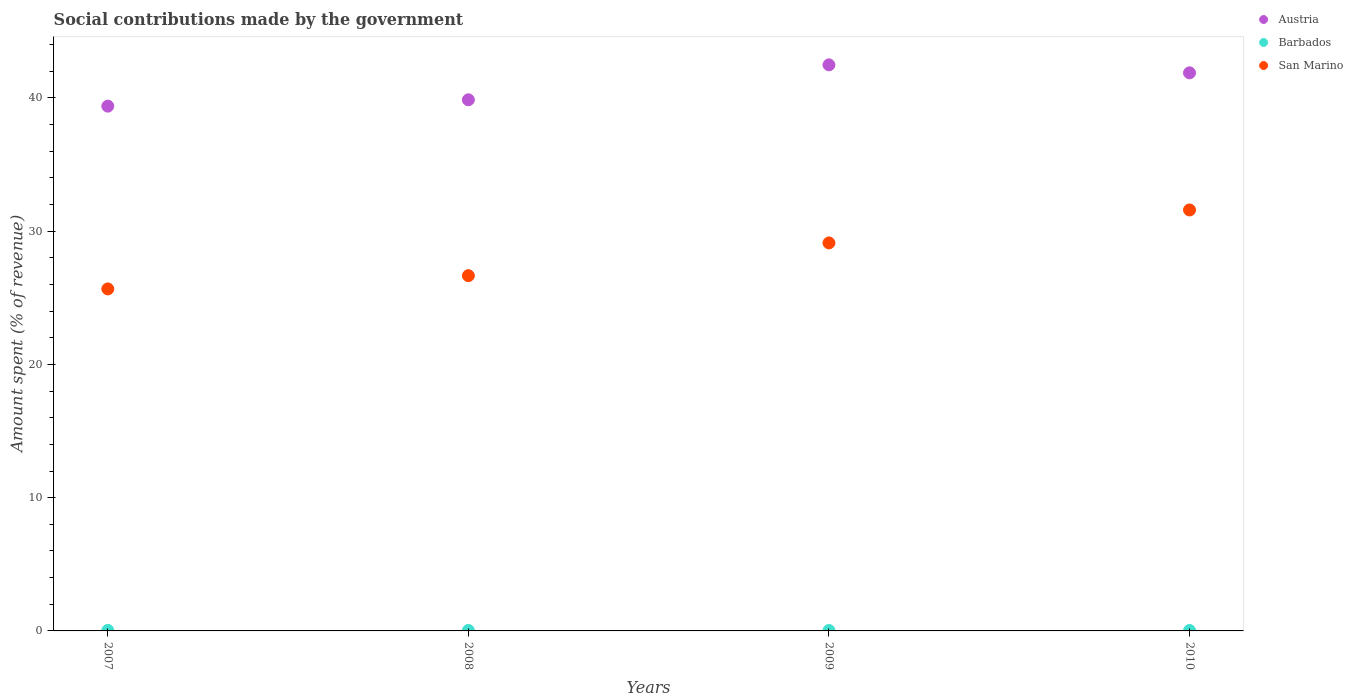How many different coloured dotlines are there?
Offer a very short reply. 3. Is the number of dotlines equal to the number of legend labels?
Offer a very short reply. Yes. What is the amount spent (in %) on social contributions in San Marino in 2010?
Provide a short and direct response. 31.59. Across all years, what is the maximum amount spent (in %) on social contributions in San Marino?
Ensure brevity in your answer.  31.59. Across all years, what is the minimum amount spent (in %) on social contributions in San Marino?
Your answer should be compact. 25.67. In which year was the amount spent (in %) on social contributions in Austria minimum?
Give a very brief answer. 2007. What is the total amount spent (in %) on social contributions in Austria in the graph?
Offer a very short reply. 163.62. What is the difference between the amount spent (in %) on social contributions in San Marino in 2009 and that in 2010?
Offer a terse response. -2.47. What is the difference between the amount spent (in %) on social contributions in Austria in 2008 and the amount spent (in %) on social contributions in Barbados in 2007?
Provide a succinct answer. 39.82. What is the average amount spent (in %) on social contributions in Barbados per year?
Provide a short and direct response. 0.03. In the year 2008, what is the difference between the amount spent (in %) on social contributions in Austria and amount spent (in %) on social contributions in Barbados?
Offer a terse response. 39.83. What is the ratio of the amount spent (in %) on social contributions in Austria in 2009 to that in 2010?
Provide a short and direct response. 1.01. Is the amount spent (in %) on social contributions in Austria in 2008 less than that in 2010?
Keep it short and to the point. Yes. Is the difference between the amount spent (in %) on social contributions in Austria in 2008 and 2009 greater than the difference between the amount spent (in %) on social contributions in Barbados in 2008 and 2009?
Keep it short and to the point. No. What is the difference between the highest and the second highest amount spent (in %) on social contributions in San Marino?
Your answer should be compact. 2.47. What is the difference between the highest and the lowest amount spent (in %) on social contributions in Austria?
Your answer should be very brief. 3.1. In how many years, is the amount spent (in %) on social contributions in San Marino greater than the average amount spent (in %) on social contributions in San Marino taken over all years?
Give a very brief answer. 2. Is the sum of the amount spent (in %) on social contributions in San Marino in 2008 and 2009 greater than the maximum amount spent (in %) on social contributions in Barbados across all years?
Your answer should be compact. Yes. Is it the case that in every year, the sum of the amount spent (in %) on social contributions in San Marino and amount spent (in %) on social contributions in Austria  is greater than the amount spent (in %) on social contributions in Barbados?
Offer a terse response. Yes. Does the amount spent (in %) on social contributions in Austria monotonically increase over the years?
Your answer should be very brief. No. Is the amount spent (in %) on social contributions in Barbados strictly greater than the amount spent (in %) on social contributions in Austria over the years?
Provide a succinct answer. No. How many dotlines are there?
Offer a terse response. 3. Are the values on the major ticks of Y-axis written in scientific E-notation?
Give a very brief answer. No. Does the graph contain grids?
Your response must be concise. No. Where does the legend appear in the graph?
Provide a short and direct response. Top right. How many legend labels are there?
Offer a terse response. 3. How are the legend labels stacked?
Make the answer very short. Vertical. What is the title of the graph?
Your answer should be very brief. Social contributions made by the government. Does "Jordan" appear as one of the legend labels in the graph?
Your answer should be compact. No. What is the label or title of the Y-axis?
Make the answer very short. Amount spent (% of revenue). What is the Amount spent (% of revenue) in Austria in 2007?
Your response must be concise. 39.39. What is the Amount spent (% of revenue) of Barbados in 2007?
Your answer should be very brief. 0.04. What is the Amount spent (% of revenue) in San Marino in 2007?
Ensure brevity in your answer.  25.67. What is the Amount spent (% of revenue) in Austria in 2008?
Provide a succinct answer. 39.86. What is the Amount spent (% of revenue) of Barbados in 2008?
Offer a very short reply. 0.04. What is the Amount spent (% of revenue) in San Marino in 2008?
Provide a succinct answer. 26.66. What is the Amount spent (% of revenue) in Austria in 2009?
Your response must be concise. 42.48. What is the Amount spent (% of revenue) in Barbados in 2009?
Offer a terse response. 0.03. What is the Amount spent (% of revenue) in San Marino in 2009?
Your response must be concise. 29.12. What is the Amount spent (% of revenue) of Austria in 2010?
Your answer should be very brief. 41.89. What is the Amount spent (% of revenue) in Barbados in 2010?
Make the answer very short. 0.03. What is the Amount spent (% of revenue) in San Marino in 2010?
Make the answer very short. 31.59. Across all years, what is the maximum Amount spent (% of revenue) of Austria?
Ensure brevity in your answer.  42.48. Across all years, what is the maximum Amount spent (% of revenue) in Barbados?
Offer a very short reply. 0.04. Across all years, what is the maximum Amount spent (% of revenue) of San Marino?
Ensure brevity in your answer.  31.59. Across all years, what is the minimum Amount spent (% of revenue) in Austria?
Offer a terse response. 39.39. Across all years, what is the minimum Amount spent (% of revenue) in Barbados?
Offer a terse response. 0.03. Across all years, what is the minimum Amount spent (% of revenue) in San Marino?
Your answer should be compact. 25.67. What is the total Amount spent (% of revenue) of Austria in the graph?
Your answer should be compact. 163.62. What is the total Amount spent (% of revenue) of Barbados in the graph?
Your response must be concise. 0.14. What is the total Amount spent (% of revenue) in San Marino in the graph?
Provide a succinct answer. 113.05. What is the difference between the Amount spent (% of revenue) of Austria in 2007 and that in 2008?
Keep it short and to the point. -0.48. What is the difference between the Amount spent (% of revenue) of Barbados in 2007 and that in 2008?
Ensure brevity in your answer.  0. What is the difference between the Amount spent (% of revenue) in San Marino in 2007 and that in 2008?
Offer a very short reply. -0.99. What is the difference between the Amount spent (% of revenue) in Austria in 2007 and that in 2009?
Make the answer very short. -3.1. What is the difference between the Amount spent (% of revenue) of Barbados in 2007 and that in 2009?
Your answer should be compact. 0.01. What is the difference between the Amount spent (% of revenue) in San Marino in 2007 and that in 2009?
Provide a succinct answer. -3.45. What is the difference between the Amount spent (% of revenue) in Austria in 2007 and that in 2010?
Offer a very short reply. -2.5. What is the difference between the Amount spent (% of revenue) of Barbados in 2007 and that in 2010?
Your answer should be very brief. 0.01. What is the difference between the Amount spent (% of revenue) in San Marino in 2007 and that in 2010?
Provide a succinct answer. -5.93. What is the difference between the Amount spent (% of revenue) of Austria in 2008 and that in 2009?
Ensure brevity in your answer.  -2.62. What is the difference between the Amount spent (% of revenue) of Barbados in 2008 and that in 2009?
Make the answer very short. 0.01. What is the difference between the Amount spent (% of revenue) in San Marino in 2008 and that in 2009?
Your answer should be very brief. -2.46. What is the difference between the Amount spent (% of revenue) in Austria in 2008 and that in 2010?
Ensure brevity in your answer.  -2.02. What is the difference between the Amount spent (% of revenue) of Barbados in 2008 and that in 2010?
Ensure brevity in your answer.  0. What is the difference between the Amount spent (% of revenue) of San Marino in 2008 and that in 2010?
Your response must be concise. -4.93. What is the difference between the Amount spent (% of revenue) in Austria in 2009 and that in 2010?
Keep it short and to the point. 0.6. What is the difference between the Amount spent (% of revenue) in Barbados in 2009 and that in 2010?
Your answer should be very brief. -0. What is the difference between the Amount spent (% of revenue) in San Marino in 2009 and that in 2010?
Your answer should be compact. -2.47. What is the difference between the Amount spent (% of revenue) in Austria in 2007 and the Amount spent (% of revenue) in Barbados in 2008?
Ensure brevity in your answer.  39.35. What is the difference between the Amount spent (% of revenue) of Austria in 2007 and the Amount spent (% of revenue) of San Marino in 2008?
Provide a succinct answer. 12.72. What is the difference between the Amount spent (% of revenue) in Barbados in 2007 and the Amount spent (% of revenue) in San Marino in 2008?
Ensure brevity in your answer.  -26.62. What is the difference between the Amount spent (% of revenue) in Austria in 2007 and the Amount spent (% of revenue) in Barbados in 2009?
Offer a very short reply. 39.36. What is the difference between the Amount spent (% of revenue) of Austria in 2007 and the Amount spent (% of revenue) of San Marino in 2009?
Provide a succinct answer. 10.27. What is the difference between the Amount spent (% of revenue) in Barbados in 2007 and the Amount spent (% of revenue) in San Marino in 2009?
Your answer should be compact. -29.08. What is the difference between the Amount spent (% of revenue) of Austria in 2007 and the Amount spent (% of revenue) of Barbados in 2010?
Give a very brief answer. 39.35. What is the difference between the Amount spent (% of revenue) of Austria in 2007 and the Amount spent (% of revenue) of San Marino in 2010?
Keep it short and to the point. 7.79. What is the difference between the Amount spent (% of revenue) of Barbados in 2007 and the Amount spent (% of revenue) of San Marino in 2010?
Your answer should be compact. -31.55. What is the difference between the Amount spent (% of revenue) in Austria in 2008 and the Amount spent (% of revenue) in Barbados in 2009?
Give a very brief answer. 39.83. What is the difference between the Amount spent (% of revenue) of Austria in 2008 and the Amount spent (% of revenue) of San Marino in 2009?
Ensure brevity in your answer.  10.74. What is the difference between the Amount spent (% of revenue) of Barbados in 2008 and the Amount spent (% of revenue) of San Marino in 2009?
Your answer should be compact. -29.08. What is the difference between the Amount spent (% of revenue) of Austria in 2008 and the Amount spent (% of revenue) of Barbados in 2010?
Provide a short and direct response. 39.83. What is the difference between the Amount spent (% of revenue) of Austria in 2008 and the Amount spent (% of revenue) of San Marino in 2010?
Provide a succinct answer. 8.27. What is the difference between the Amount spent (% of revenue) of Barbados in 2008 and the Amount spent (% of revenue) of San Marino in 2010?
Ensure brevity in your answer.  -31.56. What is the difference between the Amount spent (% of revenue) in Austria in 2009 and the Amount spent (% of revenue) in Barbados in 2010?
Ensure brevity in your answer.  42.45. What is the difference between the Amount spent (% of revenue) of Austria in 2009 and the Amount spent (% of revenue) of San Marino in 2010?
Give a very brief answer. 10.89. What is the difference between the Amount spent (% of revenue) in Barbados in 2009 and the Amount spent (% of revenue) in San Marino in 2010?
Give a very brief answer. -31.56. What is the average Amount spent (% of revenue) of Austria per year?
Provide a short and direct response. 40.9. What is the average Amount spent (% of revenue) of Barbados per year?
Make the answer very short. 0.03. What is the average Amount spent (% of revenue) in San Marino per year?
Offer a terse response. 28.26. In the year 2007, what is the difference between the Amount spent (% of revenue) in Austria and Amount spent (% of revenue) in Barbados?
Your response must be concise. 39.35. In the year 2007, what is the difference between the Amount spent (% of revenue) of Austria and Amount spent (% of revenue) of San Marino?
Your answer should be compact. 13.72. In the year 2007, what is the difference between the Amount spent (% of revenue) of Barbados and Amount spent (% of revenue) of San Marino?
Provide a short and direct response. -25.63. In the year 2008, what is the difference between the Amount spent (% of revenue) of Austria and Amount spent (% of revenue) of Barbados?
Ensure brevity in your answer.  39.83. In the year 2008, what is the difference between the Amount spent (% of revenue) of Austria and Amount spent (% of revenue) of San Marino?
Your response must be concise. 13.2. In the year 2008, what is the difference between the Amount spent (% of revenue) in Barbados and Amount spent (% of revenue) in San Marino?
Provide a succinct answer. -26.63. In the year 2009, what is the difference between the Amount spent (% of revenue) of Austria and Amount spent (% of revenue) of Barbados?
Keep it short and to the point. 42.45. In the year 2009, what is the difference between the Amount spent (% of revenue) of Austria and Amount spent (% of revenue) of San Marino?
Offer a terse response. 13.36. In the year 2009, what is the difference between the Amount spent (% of revenue) of Barbados and Amount spent (% of revenue) of San Marino?
Your response must be concise. -29.09. In the year 2010, what is the difference between the Amount spent (% of revenue) of Austria and Amount spent (% of revenue) of Barbados?
Ensure brevity in your answer.  41.85. In the year 2010, what is the difference between the Amount spent (% of revenue) of Austria and Amount spent (% of revenue) of San Marino?
Your answer should be very brief. 10.29. In the year 2010, what is the difference between the Amount spent (% of revenue) of Barbados and Amount spent (% of revenue) of San Marino?
Give a very brief answer. -31.56. What is the ratio of the Amount spent (% of revenue) in Barbados in 2007 to that in 2008?
Give a very brief answer. 1.12. What is the ratio of the Amount spent (% of revenue) of San Marino in 2007 to that in 2008?
Make the answer very short. 0.96. What is the ratio of the Amount spent (% of revenue) in Austria in 2007 to that in 2009?
Make the answer very short. 0.93. What is the ratio of the Amount spent (% of revenue) in Barbados in 2007 to that in 2009?
Provide a short and direct response. 1.35. What is the ratio of the Amount spent (% of revenue) in San Marino in 2007 to that in 2009?
Keep it short and to the point. 0.88. What is the ratio of the Amount spent (% of revenue) of Austria in 2007 to that in 2010?
Offer a terse response. 0.94. What is the ratio of the Amount spent (% of revenue) in Barbados in 2007 to that in 2010?
Provide a short and direct response. 1.25. What is the ratio of the Amount spent (% of revenue) in San Marino in 2007 to that in 2010?
Offer a terse response. 0.81. What is the ratio of the Amount spent (% of revenue) in Austria in 2008 to that in 2009?
Make the answer very short. 0.94. What is the ratio of the Amount spent (% of revenue) of Barbados in 2008 to that in 2009?
Provide a short and direct response. 1.21. What is the ratio of the Amount spent (% of revenue) in San Marino in 2008 to that in 2009?
Ensure brevity in your answer.  0.92. What is the ratio of the Amount spent (% of revenue) of Austria in 2008 to that in 2010?
Keep it short and to the point. 0.95. What is the ratio of the Amount spent (% of revenue) in Barbados in 2008 to that in 2010?
Your response must be concise. 1.12. What is the ratio of the Amount spent (% of revenue) in San Marino in 2008 to that in 2010?
Give a very brief answer. 0.84. What is the ratio of the Amount spent (% of revenue) of Austria in 2009 to that in 2010?
Provide a succinct answer. 1.01. What is the ratio of the Amount spent (% of revenue) in Barbados in 2009 to that in 2010?
Offer a terse response. 0.92. What is the ratio of the Amount spent (% of revenue) in San Marino in 2009 to that in 2010?
Give a very brief answer. 0.92. What is the difference between the highest and the second highest Amount spent (% of revenue) of Austria?
Give a very brief answer. 0.6. What is the difference between the highest and the second highest Amount spent (% of revenue) in Barbados?
Your answer should be compact. 0. What is the difference between the highest and the second highest Amount spent (% of revenue) in San Marino?
Provide a succinct answer. 2.47. What is the difference between the highest and the lowest Amount spent (% of revenue) of Austria?
Make the answer very short. 3.1. What is the difference between the highest and the lowest Amount spent (% of revenue) of Barbados?
Offer a very short reply. 0.01. What is the difference between the highest and the lowest Amount spent (% of revenue) of San Marino?
Give a very brief answer. 5.93. 